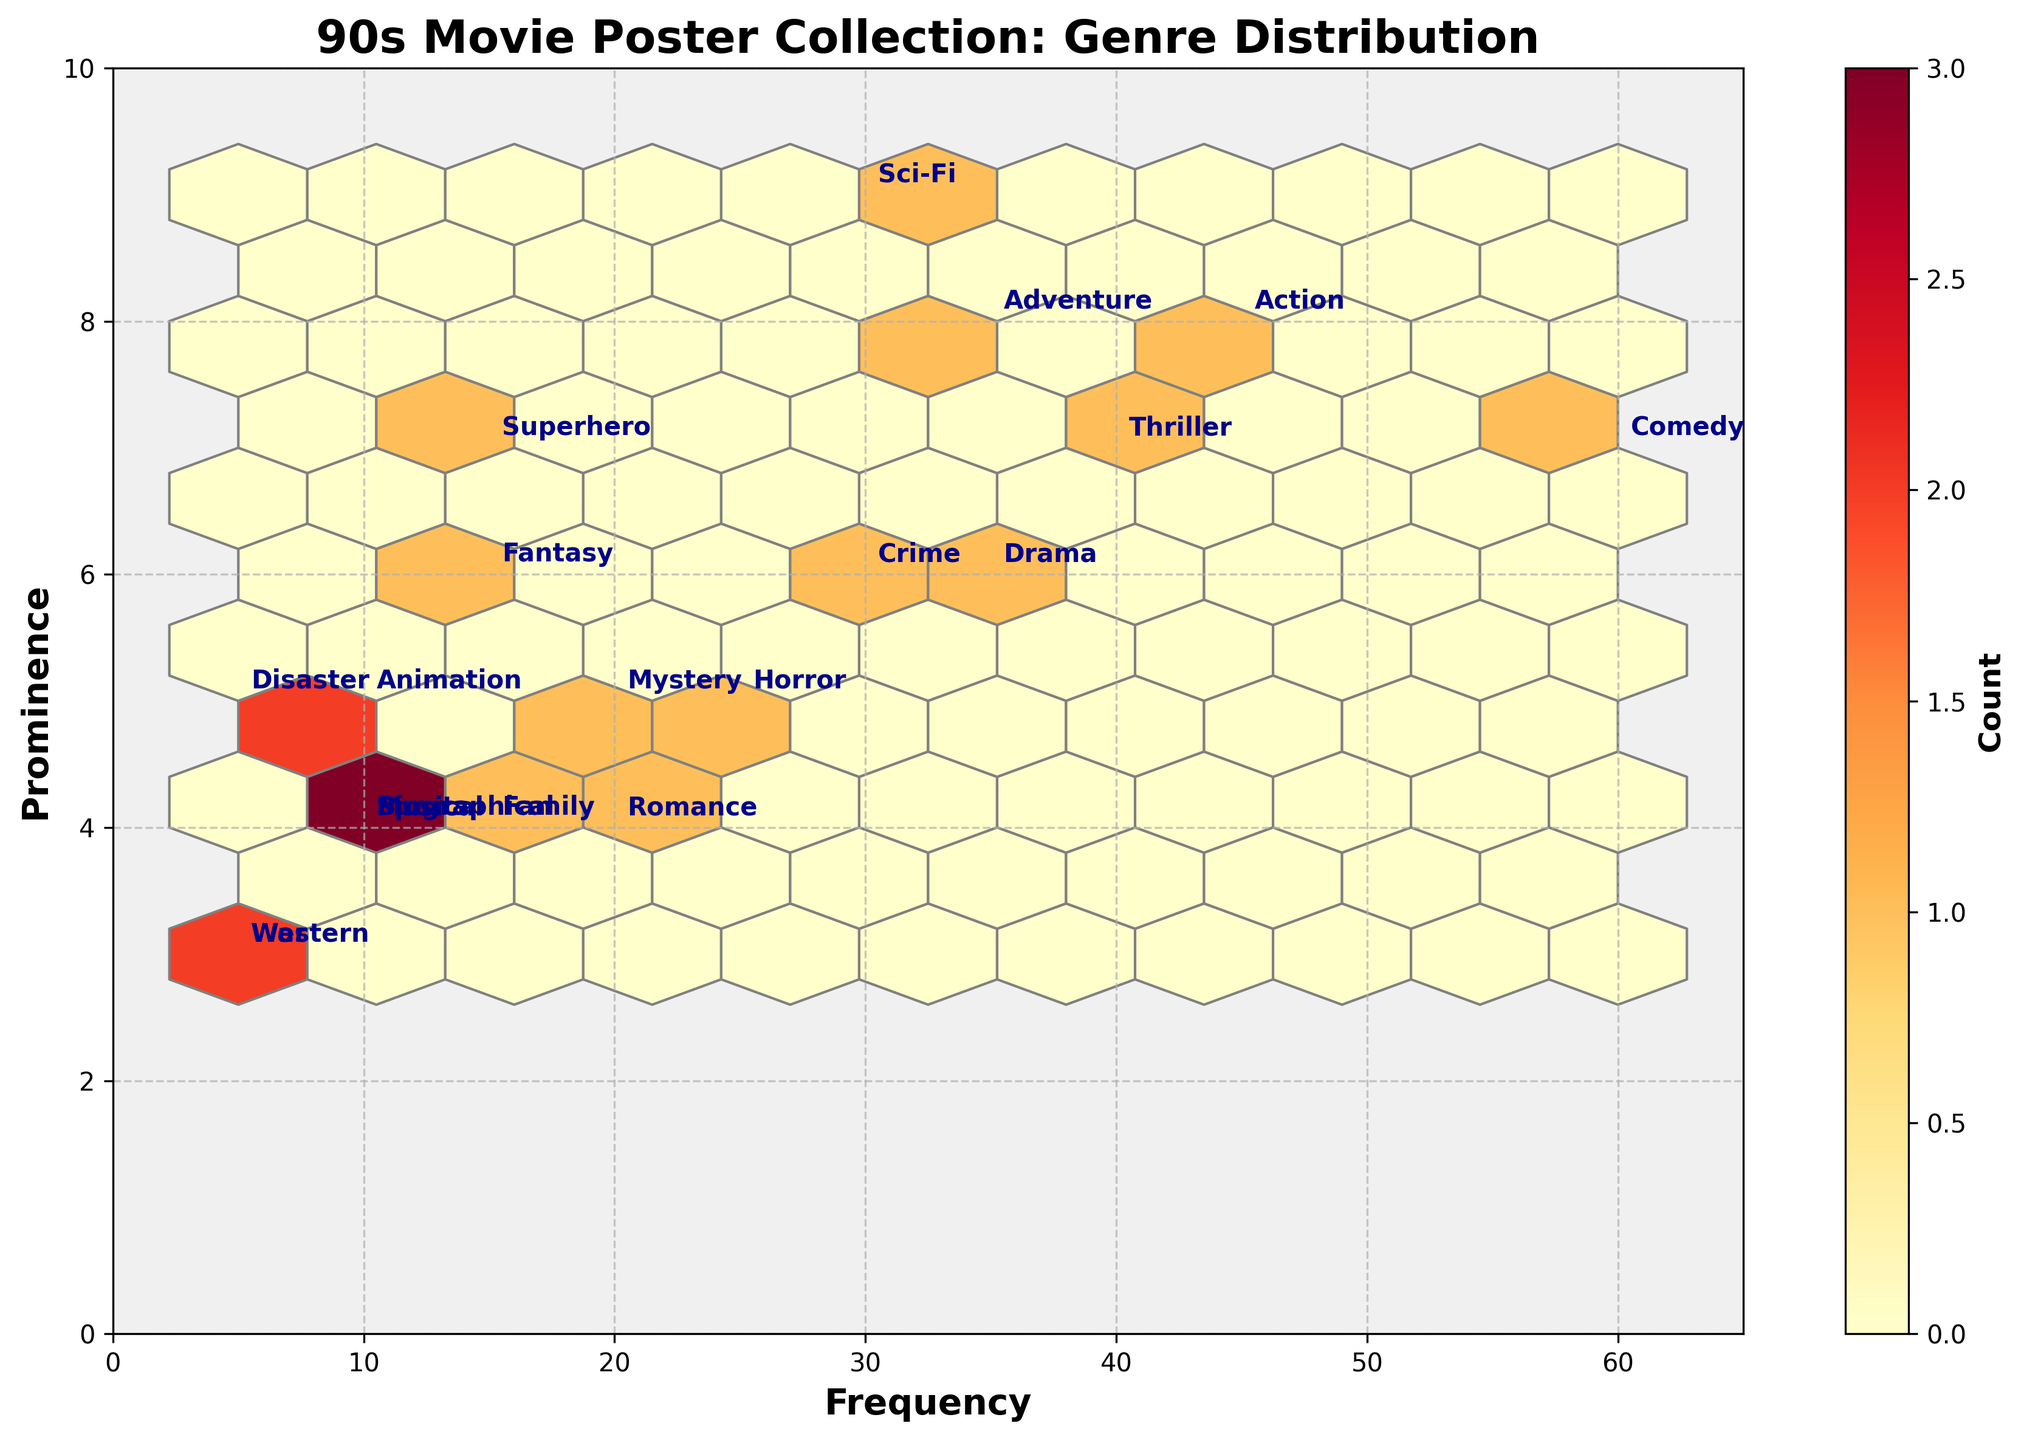what are the most prominent genres in the collection? For figuring out the most prominent genres, we observe the y-axis labeled Prominence and find the highest values. The highest prominence values (9 and 8) are found for Sci-Fi, Action, and Adventure genres.
Answer: Sci-Fi, Action, Adventure How many genres have a frequency greater than 30? We need to count the number of genres where the x-axis value labeled Frequency is greater than 30. These genres are Action, Comedy, Drama, Thriller, and Adventure.
Answer: 5 Which genre has the highest Frequency and Prominence? By examining the highest points in both axes, the genre with the highest Frequency (60) and notable prominence (7) is Comedy.
Answer: Comedy Which genres have a prominence of 6? Looking at the y-axis for the Prominence value of 6, the associated genres are Drama, Fantasy, Crime.
Answer: Drama, Fantasy, Crime What is the total number of genres represented in the plot? We can count the distinct genre names provided as annotations in the plot. The total number of genres represented is 20.
Answer: 20 Is there any genre that is equally balanced in Frequency and Prominence? We need to find a genre where the values on both the x (Frequency) and y (Prominence) axes are the same. No such genre exists in the dataset.
Answer: No Which genre is more frequent, Horror or Crime? By comparing the x-axis values, Horror has a frequency of 25 while Crime has a frequency of 30. So, Crime is more frequent than Horror.
Answer: Crime What's the average prominence of genres with a frequency below 20? Identifying genres with frequencies below 20: Fantasy, Animation, Western, Musical, War, Sports, Disaster, Biographical. Their prominence values are 6, 5, 3, 4, 3, 4, 5, 4 respectively. Sum is 34, count is 8. Average = 34/8 = 4.25.
Answer: 4.25 How many genres have both frequencies above 30 and prominences above 6? We need to find genres where both x-axis values (Frequency > 30) and y-axis values (Prominence > 6) conditions are met. Those are Action, Comedy, Thriller, Adventure, Sci-Fi.
Answer: 5 